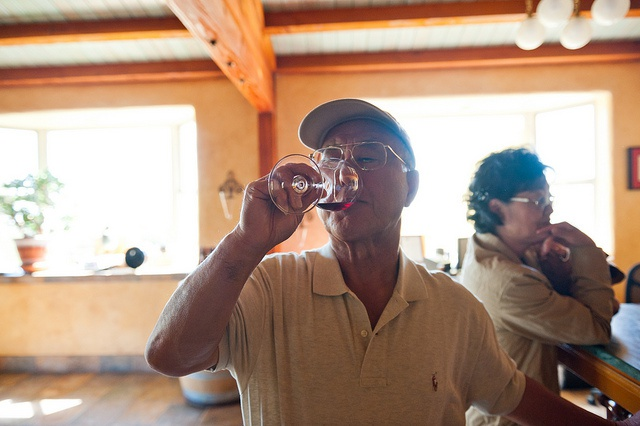Describe the objects in this image and their specific colors. I can see people in beige, brown, maroon, and gray tones, people in beige, gray, maroon, and black tones, wine glass in beige, brown, purple, and darkgray tones, dining table in beige, black, maroon, teal, and brown tones, and potted plant in beige, ivory, and tan tones in this image. 